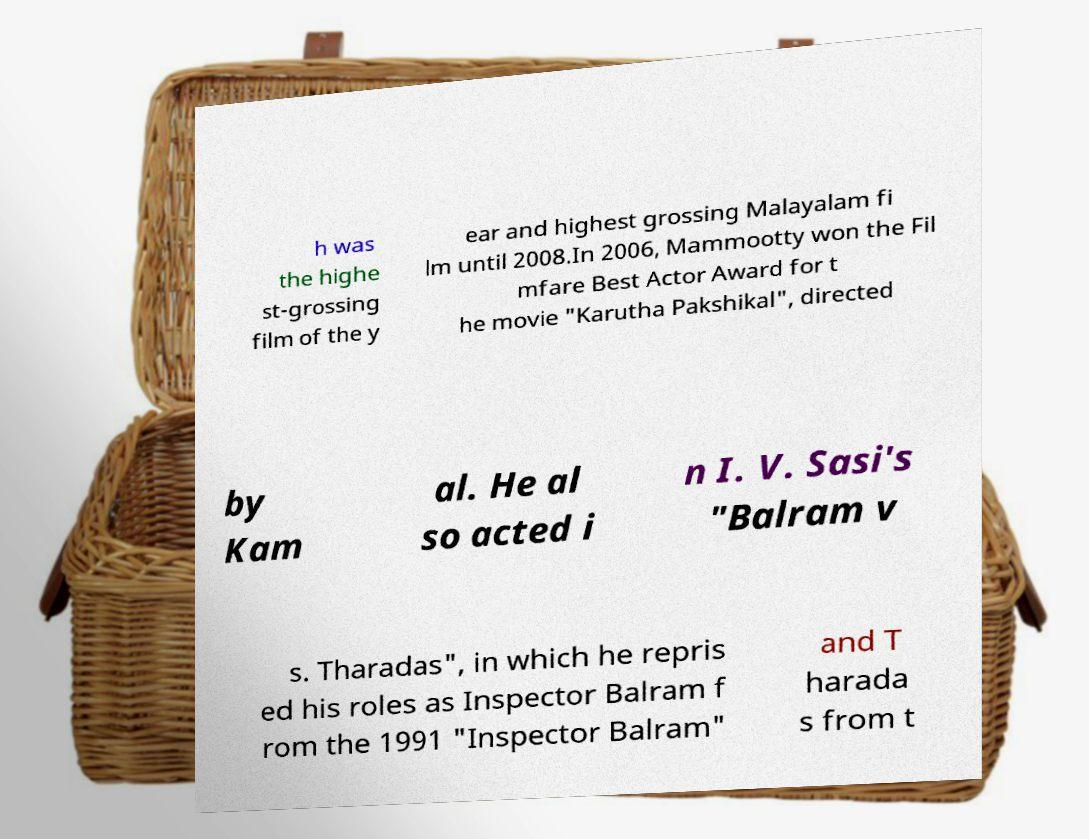For documentation purposes, I need the text within this image transcribed. Could you provide that? h was the highe st-grossing film of the y ear and highest grossing Malayalam fi lm until 2008.In 2006, Mammootty won the Fil mfare Best Actor Award for t he movie "Karutha Pakshikal", directed by Kam al. He al so acted i n I. V. Sasi's "Balram v s. Tharadas", in which he repris ed his roles as Inspector Balram f rom the 1991 "Inspector Balram" and T harada s from t 